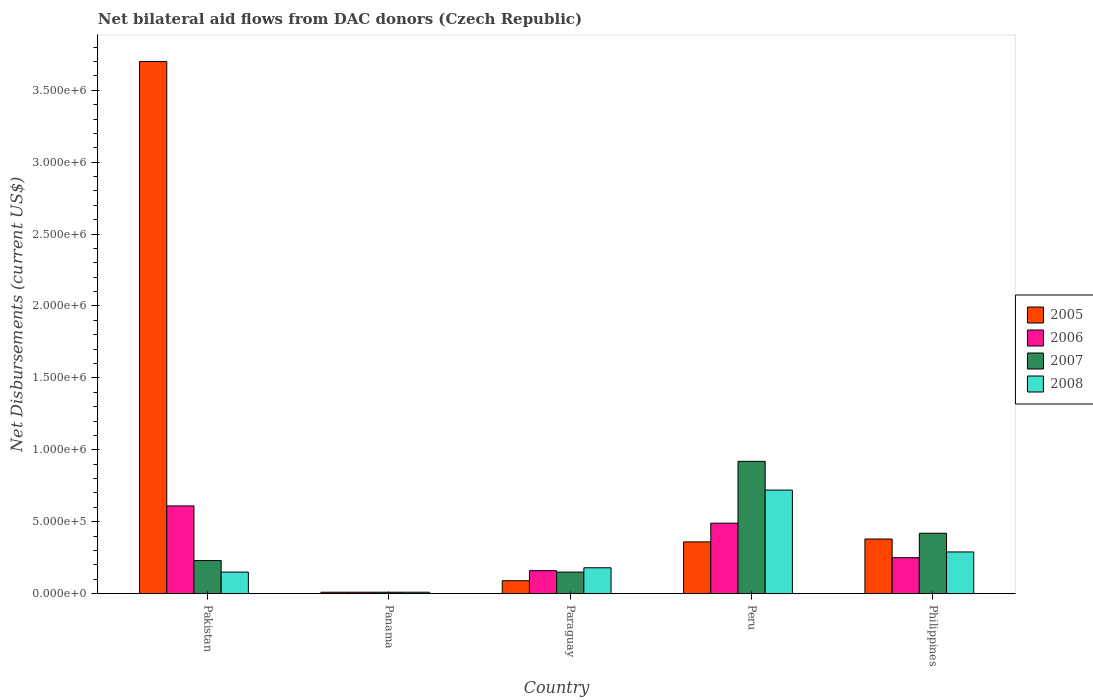How many bars are there on the 2nd tick from the right?
Your answer should be compact. 4. Across all countries, what is the maximum net bilateral aid flows in 2005?
Offer a terse response. 3.70e+06. In which country was the net bilateral aid flows in 2006 maximum?
Keep it short and to the point. Pakistan. In which country was the net bilateral aid flows in 2007 minimum?
Offer a terse response. Panama. What is the total net bilateral aid flows in 2005 in the graph?
Give a very brief answer. 4.54e+06. What is the difference between the net bilateral aid flows in 2005 in Pakistan and that in Peru?
Your response must be concise. 3.34e+06. What is the difference between the net bilateral aid flows in 2007 in Paraguay and the net bilateral aid flows in 2006 in Pakistan?
Give a very brief answer. -4.60e+05. What is the average net bilateral aid flows in 2006 per country?
Make the answer very short. 3.04e+05. What is the difference between the net bilateral aid flows of/in 2005 and net bilateral aid flows of/in 2007 in Pakistan?
Offer a very short reply. 3.47e+06. In how many countries, is the net bilateral aid flows in 2007 greater than 1800000 US$?
Your answer should be compact. 0. What is the difference between the highest and the second highest net bilateral aid flows in 2005?
Offer a terse response. 3.34e+06. What is the difference between the highest and the lowest net bilateral aid flows in 2005?
Keep it short and to the point. 3.69e+06. In how many countries, is the net bilateral aid flows in 2006 greater than the average net bilateral aid flows in 2006 taken over all countries?
Your answer should be compact. 2. Is the sum of the net bilateral aid flows in 2007 in Pakistan and Peru greater than the maximum net bilateral aid flows in 2006 across all countries?
Give a very brief answer. Yes. Is it the case that in every country, the sum of the net bilateral aid flows in 2006 and net bilateral aid flows in 2005 is greater than the sum of net bilateral aid flows in 2007 and net bilateral aid flows in 2008?
Ensure brevity in your answer.  No. What does the 3rd bar from the left in Philippines represents?
Give a very brief answer. 2007. Are all the bars in the graph horizontal?
Provide a succinct answer. No. Are the values on the major ticks of Y-axis written in scientific E-notation?
Your response must be concise. Yes. Does the graph contain any zero values?
Give a very brief answer. No. Does the graph contain grids?
Offer a terse response. No. What is the title of the graph?
Offer a very short reply. Net bilateral aid flows from DAC donors (Czech Republic). Does "1984" appear as one of the legend labels in the graph?
Give a very brief answer. No. What is the label or title of the Y-axis?
Offer a very short reply. Net Disbursements (current US$). What is the Net Disbursements (current US$) in 2005 in Pakistan?
Give a very brief answer. 3.70e+06. What is the Net Disbursements (current US$) in 2008 in Pakistan?
Your response must be concise. 1.50e+05. What is the Net Disbursements (current US$) in 2005 in Panama?
Offer a terse response. 10000. What is the Net Disbursements (current US$) of 2005 in Paraguay?
Keep it short and to the point. 9.00e+04. What is the Net Disbursements (current US$) of 2007 in Paraguay?
Provide a short and direct response. 1.50e+05. What is the Net Disbursements (current US$) of 2005 in Peru?
Provide a succinct answer. 3.60e+05. What is the Net Disbursements (current US$) in 2006 in Peru?
Provide a succinct answer. 4.90e+05. What is the Net Disbursements (current US$) of 2007 in Peru?
Provide a succinct answer. 9.20e+05. What is the Net Disbursements (current US$) of 2008 in Peru?
Make the answer very short. 7.20e+05. What is the Net Disbursements (current US$) of 2006 in Philippines?
Your answer should be very brief. 2.50e+05. What is the Net Disbursements (current US$) in 2007 in Philippines?
Your answer should be very brief. 4.20e+05. Across all countries, what is the maximum Net Disbursements (current US$) in 2005?
Offer a very short reply. 3.70e+06. Across all countries, what is the maximum Net Disbursements (current US$) of 2007?
Provide a succinct answer. 9.20e+05. Across all countries, what is the maximum Net Disbursements (current US$) of 2008?
Offer a terse response. 7.20e+05. Across all countries, what is the minimum Net Disbursements (current US$) in 2007?
Your answer should be compact. 10000. What is the total Net Disbursements (current US$) in 2005 in the graph?
Your answer should be very brief. 4.54e+06. What is the total Net Disbursements (current US$) in 2006 in the graph?
Your answer should be compact. 1.52e+06. What is the total Net Disbursements (current US$) of 2007 in the graph?
Offer a terse response. 1.73e+06. What is the total Net Disbursements (current US$) in 2008 in the graph?
Offer a terse response. 1.35e+06. What is the difference between the Net Disbursements (current US$) of 2005 in Pakistan and that in Panama?
Keep it short and to the point. 3.69e+06. What is the difference between the Net Disbursements (current US$) of 2006 in Pakistan and that in Panama?
Your answer should be very brief. 6.00e+05. What is the difference between the Net Disbursements (current US$) in 2005 in Pakistan and that in Paraguay?
Make the answer very short. 3.61e+06. What is the difference between the Net Disbursements (current US$) of 2006 in Pakistan and that in Paraguay?
Your answer should be compact. 4.50e+05. What is the difference between the Net Disbursements (current US$) of 2007 in Pakistan and that in Paraguay?
Provide a short and direct response. 8.00e+04. What is the difference between the Net Disbursements (current US$) in 2005 in Pakistan and that in Peru?
Your answer should be very brief. 3.34e+06. What is the difference between the Net Disbursements (current US$) in 2007 in Pakistan and that in Peru?
Ensure brevity in your answer.  -6.90e+05. What is the difference between the Net Disbursements (current US$) of 2008 in Pakistan and that in Peru?
Offer a very short reply. -5.70e+05. What is the difference between the Net Disbursements (current US$) in 2005 in Pakistan and that in Philippines?
Your answer should be compact. 3.32e+06. What is the difference between the Net Disbursements (current US$) in 2006 in Pakistan and that in Philippines?
Offer a very short reply. 3.60e+05. What is the difference between the Net Disbursements (current US$) of 2007 in Pakistan and that in Philippines?
Give a very brief answer. -1.90e+05. What is the difference between the Net Disbursements (current US$) in 2005 in Panama and that in Paraguay?
Offer a terse response. -8.00e+04. What is the difference between the Net Disbursements (current US$) in 2006 in Panama and that in Paraguay?
Offer a very short reply. -1.50e+05. What is the difference between the Net Disbursements (current US$) in 2005 in Panama and that in Peru?
Provide a succinct answer. -3.50e+05. What is the difference between the Net Disbursements (current US$) of 2006 in Panama and that in Peru?
Your response must be concise. -4.80e+05. What is the difference between the Net Disbursements (current US$) in 2007 in Panama and that in Peru?
Offer a terse response. -9.10e+05. What is the difference between the Net Disbursements (current US$) of 2008 in Panama and that in Peru?
Your response must be concise. -7.10e+05. What is the difference between the Net Disbursements (current US$) of 2005 in Panama and that in Philippines?
Provide a succinct answer. -3.70e+05. What is the difference between the Net Disbursements (current US$) of 2006 in Panama and that in Philippines?
Provide a succinct answer. -2.40e+05. What is the difference between the Net Disbursements (current US$) in 2007 in Panama and that in Philippines?
Your response must be concise. -4.10e+05. What is the difference between the Net Disbursements (current US$) of 2008 in Panama and that in Philippines?
Offer a very short reply. -2.80e+05. What is the difference between the Net Disbursements (current US$) in 2006 in Paraguay and that in Peru?
Make the answer very short. -3.30e+05. What is the difference between the Net Disbursements (current US$) of 2007 in Paraguay and that in Peru?
Give a very brief answer. -7.70e+05. What is the difference between the Net Disbursements (current US$) in 2008 in Paraguay and that in Peru?
Your response must be concise. -5.40e+05. What is the difference between the Net Disbursements (current US$) of 2005 in Paraguay and that in Philippines?
Provide a short and direct response. -2.90e+05. What is the difference between the Net Disbursements (current US$) in 2008 in Paraguay and that in Philippines?
Offer a terse response. -1.10e+05. What is the difference between the Net Disbursements (current US$) in 2005 in Peru and that in Philippines?
Make the answer very short. -2.00e+04. What is the difference between the Net Disbursements (current US$) of 2005 in Pakistan and the Net Disbursements (current US$) of 2006 in Panama?
Offer a very short reply. 3.69e+06. What is the difference between the Net Disbursements (current US$) of 2005 in Pakistan and the Net Disbursements (current US$) of 2007 in Panama?
Ensure brevity in your answer.  3.69e+06. What is the difference between the Net Disbursements (current US$) in 2005 in Pakistan and the Net Disbursements (current US$) in 2008 in Panama?
Provide a short and direct response. 3.69e+06. What is the difference between the Net Disbursements (current US$) of 2006 in Pakistan and the Net Disbursements (current US$) of 2007 in Panama?
Make the answer very short. 6.00e+05. What is the difference between the Net Disbursements (current US$) of 2007 in Pakistan and the Net Disbursements (current US$) of 2008 in Panama?
Your answer should be very brief. 2.20e+05. What is the difference between the Net Disbursements (current US$) of 2005 in Pakistan and the Net Disbursements (current US$) of 2006 in Paraguay?
Provide a short and direct response. 3.54e+06. What is the difference between the Net Disbursements (current US$) of 2005 in Pakistan and the Net Disbursements (current US$) of 2007 in Paraguay?
Offer a terse response. 3.55e+06. What is the difference between the Net Disbursements (current US$) in 2005 in Pakistan and the Net Disbursements (current US$) in 2008 in Paraguay?
Provide a succinct answer. 3.52e+06. What is the difference between the Net Disbursements (current US$) of 2006 in Pakistan and the Net Disbursements (current US$) of 2007 in Paraguay?
Offer a very short reply. 4.60e+05. What is the difference between the Net Disbursements (current US$) in 2006 in Pakistan and the Net Disbursements (current US$) in 2008 in Paraguay?
Ensure brevity in your answer.  4.30e+05. What is the difference between the Net Disbursements (current US$) in 2007 in Pakistan and the Net Disbursements (current US$) in 2008 in Paraguay?
Keep it short and to the point. 5.00e+04. What is the difference between the Net Disbursements (current US$) in 2005 in Pakistan and the Net Disbursements (current US$) in 2006 in Peru?
Provide a short and direct response. 3.21e+06. What is the difference between the Net Disbursements (current US$) in 2005 in Pakistan and the Net Disbursements (current US$) in 2007 in Peru?
Your response must be concise. 2.78e+06. What is the difference between the Net Disbursements (current US$) of 2005 in Pakistan and the Net Disbursements (current US$) of 2008 in Peru?
Your answer should be very brief. 2.98e+06. What is the difference between the Net Disbursements (current US$) of 2006 in Pakistan and the Net Disbursements (current US$) of 2007 in Peru?
Ensure brevity in your answer.  -3.10e+05. What is the difference between the Net Disbursements (current US$) of 2007 in Pakistan and the Net Disbursements (current US$) of 2008 in Peru?
Your response must be concise. -4.90e+05. What is the difference between the Net Disbursements (current US$) of 2005 in Pakistan and the Net Disbursements (current US$) of 2006 in Philippines?
Make the answer very short. 3.45e+06. What is the difference between the Net Disbursements (current US$) of 2005 in Pakistan and the Net Disbursements (current US$) of 2007 in Philippines?
Provide a succinct answer. 3.28e+06. What is the difference between the Net Disbursements (current US$) of 2005 in Pakistan and the Net Disbursements (current US$) of 2008 in Philippines?
Offer a terse response. 3.41e+06. What is the difference between the Net Disbursements (current US$) in 2006 in Pakistan and the Net Disbursements (current US$) in 2007 in Philippines?
Provide a short and direct response. 1.90e+05. What is the difference between the Net Disbursements (current US$) in 2006 in Pakistan and the Net Disbursements (current US$) in 2008 in Philippines?
Keep it short and to the point. 3.20e+05. What is the difference between the Net Disbursements (current US$) in 2007 in Pakistan and the Net Disbursements (current US$) in 2008 in Philippines?
Offer a very short reply. -6.00e+04. What is the difference between the Net Disbursements (current US$) of 2005 in Panama and the Net Disbursements (current US$) of 2006 in Peru?
Ensure brevity in your answer.  -4.80e+05. What is the difference between the Net Disbursements (current US$) of 2005 in Panama and the Net Disbursements (current US$) of 2007 in Peru?
Give a very brief answer. -9.10e+05. What is the difference between the Net Disbursements (current US$) in 2005 in Panama and the Net Disbursements (current US$) in 2008 in Peru?
Provide a short and direct response. -7.10e+05. What is the difference between the Net Disbursements (current US$) of 2006 in Panama and the Net Disbursements (current US$) of 2007 in Peru?
Your answer should be compact. -9.10e+05. What is the difference between the Net Disbursements (current US$) of 2006 in Panama and the Net Disbursements (current US$) of 2008 in Peru?
Your answer should be compact. -7.10e+05. What is the difference between the Net Disbursements (current US$) of 2007 in Panama and the Net Disbursements (current US$) of 2008 in Peru?
Offer a terse response. -7.10e+05. What is the difference between the Net Disbursements (current US$) of 2005 in Panama and the Net Disbursements (current US$) of 2007 in Philippines?
Ensure brevity in your answer.  -4.10e+05. What is the difference between the Net Disbursements (current US$) in 2005 in Panama and the Net Disbursements (current US$) in 2008 in Philippines?
Offer a very short reply. -2.80e+05. What is the difference between the Net Disbursements (current US$) of 2006 in Panama and the Net Disbursements (current US$) of 2007 in Philippines?
Keep it short and to the point. -4.10e+05. What is the difference between the Net Disbursements (current US$) in 2006 in Panama and the Net Disbursements (current US$) in 2008 in Philippines?
Provide a short and direct response. -2.80e+05. What is the difference between the Net Disbursements (current US$) in 2007 in Panama and the Net Disbursements (current US$) in 2008 in Philippines?
Give a very brief answer. -2.80e+05. What is the difference between the Net Disbursements (current US$) in 2005 in Paraguay and the Net Disbursements (current US$) in 2006 in Peru?
Your answer should be very brief. -4.00e+05. What is the difference between the Net Disbursements (current US$) in 2005 in Paraguay and the Net Disbursements (current US$) in 2007 in Peru?
Your response must be concise. -8.30e+05. What is the difference between the Net Disbursements (current US$) of 2005 in Paraguay and the Net Disbursements (current US$) of 2008 in Peru?
Your answer should be compact. -6.30e+05. What is the difference between the Net Disbursements (current US$) of 2006 in Paraguay and the Net Disbursements (current US$) of 2007 in Peru?
Give a very brief answer. -7.60e+05. What is the difference between the Net Disbursements (current US$) in 2006 in Paraguay and the Net Disbursements (current US$) in 2008 in Peru?
Keep it short and to the point. -5.60e+05. What is the difference between the Net Disbursements (current US$) of 2007 in Paraguay and the Net Disbursements (current US$) of 2008 in Peru?
Ensure brevity in your answer.  -5.70e+05. What is the difference between the Net Disbursements (current US$) in 2005 in Paraguay and the Net Disbursements (current US$) in 2006 in Philippines?
Your answer should be compact. -1.60e+05. What is the difference between the Net Disbursements (current US$) of 2005 in Paraguay and the Net Disbursements (current US$) of 2007 in Philippines?
Provide a succinct answer. -3.30e+05. What is the difference between the Net Disbursements (current US$) of 2007 in Paraguay and the Net Disbursements (current US$) of 2008 in Philippines?
Make the answer very short. -1.40e+05. What is the difference between the Net Disbursements (current US$) in 2005 in Peru and the Net Disbursements (current US$) in 2006 in Philippines?
Your answer should be very brief. 1.10e+05. What is the difference between the Net Disbursements (current US$) in 2005 in Peru and the Net Disbursements (current US$) in 2008 in Philippines?
Make the answer very short. 7.00e+04. What is the difference between the Net Disbursements (current US$) in 2006 in Peru and the Net Disbursements (current US$) in 2008 in Philippines?
Offer a very short reply. 2.00e+05. What is the difference between the Net Disbursements (current US$) of 2007 in Peru and the Net Disbursements (current US$) of 2008 in Philippines?
Your answer should be very brief. 6.30e+05. What is the average Net Disbursements (current US$) in 2005 per country?
Give a very brief answer. 9.08e+05. What is the average Net Disbursements (current US$) in 2006 per country?
Ensure brevity in your answer.  3.04e+05. What is the average Net Disbursements (current US$) of 2007 per country?
Your answer should be very brief. 3.46e+05. What is the average Net Disbursements (current US$) of 2008 per country?
Your response must be concise. 2.70e+05. What is the difference between the Net Disbursements (current US$) of 2005 and Net Disbursements (current US$) of 2006 in Pakistan?
Offer a very short reply. 3.09e+06. What is the difference between the Net Disbursements (current US$) of 2005 and Net Disbursements (current US$) of 2007 in Pakistan?
Provide a short and direct response. 3.47e+06. What is the difference between the Net Disbursements (current US$) in 2005 and Net Disbursements (current US$) in 2008 in Pakistan?
Provide a short and direct response. 3.55e+06. What is the difference between the Net Disbursements (current US$) of 2006 and Net Disbursements (current US$) of 2007 in Pakistan?
Your answer should be very brief. 3.80e+05. What is the difference between the Net Disbursements (current US$) in 2006 and Net Disbursements (current US$) in 2008 in Pakistan?
Your response must be concise. 4.60e+05. What is the difference between the Net Disbursements (current US$) of 2005 and Net Disbursements (current US$) of 2006 in Panama?
Your answer should be compact. 0. What is the difference between the Net Disbursements (current US$) of 2005 and Net Disbursements (current US$) of 2007 in Panama?
Make the answer very short. 0. What is the difference between the Net Disbursements (current US$) in 2006 and Net Disbursements (current US$) in 2007 in Panama?
Offer a very short reply. 0. What is the difference between the Net Disbursements (current US$) of 2006 and Net Disbursements (current US$) of 2008 in Panama?
Ensure brevity in your answer.  0. What is the difference between the Net Disbursements (current US$) of 2007 and Net Disbursements (current US$) of 2008 in Panama?
Ensure brevity in your answer.  0. What is the difference between the Net Disbursements (current US$) in 2005 and Net Disbursements (current US$) in 2006 in Paraguay?
Offer a terse response. -7.00e+04. What is the difference between the Net Disbursements (current US$) of 2005 and Net Disbursements (current US$) of 2007 in Paraguay?
Offer a very short reply. -6.00e+04. What is the difference between the Net Disbursements (current US$) in 2005 and Net Disbursements (current US$) in 2006 in Peru?
Offer a terse response. -1.30e+05. What is the difference between the Net Disbursements (current US$) in 2005 and Net Disbursements (current US$) in 2007 in Peru?
Offer a very short reply. -5.60e+05. What is the difference between the Net Disbursements (current US$) of 2005 and Net Disbursements (current US$) of 2008 in Peru?
Your response must be concise. -3.60e+05. What is the difference between the Net Disbursements (current US$) in 2006 and Net Disbursements (current US$) in 2007 in Peru?
Make the answer very short. -4.30e+05. What is the difference between the Net Disbursements (current US$) of 2005 and Net Disbursements (current US$) of 2006 in Philippines?
Your answer should be very brief. 1.30e+05. What is the difference between the Net Disbursements (current US$) in 2006 and Net Disbursements (current US$) in 2007 in Philippines?
Offer a very short reply. -1.70e+05. What is the ratio of the Net Disbursements (current US$) of 2005 in Pakistan to that in Panama?
Ensure brevity in your answer.  370. What is the ratio of the Net Disbursements (current US$) of 2006 in Pakistan to that in Panama?
Make the answer very short. 61. What is the ratio of the Net Disbursements (current US$) in 2008 in Pakistan to that in Panama?
Your response must be concise. 15. What is the ratio of the Net Disbursements (current US$) of 2005 in Pakistan to that in Paraguay?
Offer a terse response. 41.11. What is the ratio of the Net Disbursements (current US$) in 2006 in Pakistan to that in Paraguay?
Keep it short and to the point. 3.81. What is the ratio of the Net Disbursements (current US$) in 2007 in Pakistan to that in Paraguay?
Offer a terse response. 1.53. What is the ratio of the Net Disbursements (current US$) in 2005 in Pakistan to that in Peru?
Ensure brevity in your answer.  10.28. What is the ratio of the Net Disbursements (current US$) of 2006 in Pakistan to that in Peru?
Your answer should be very brief. 1.24. What is the ratio of the Net Disbursements (current US$) in 2007 in Pakistan to that in Peru?
Keep it short and to the point. 0.25. What is the ratio of the Net Disbursements (current US$) in 2008 in Pakistan to that in Peru?
Keep it short and to the point. 0.21. What is the ratio of the Net Disbursements (current US$) of 2005 in Pakistan to that in Philippines?
Give a very brief answer. 9.74. What is the ratio of the Net Disbursements (current US$) of 2006 in Pakistan to that in Philippines?
Make the answer very short. 2.44. What is the ratio of the Net Disbursements (current US$) in 2007 in Pakistan to that in Philippines?
Ensure brevity in your answer.  0.55. What is the ratio of the Net Disbursements (current US$) in 2008 in Pakistan to that in Philippines?
Make the answer very short. 0.52. What is the ratio of the Net Disbursements (current US$) in 2006 in Panama to that in Paraguay?
Keep it short and to the point. 0.06. What is the ratio of the Net Disbursements (current US$) of 2007 in Panama to that in Paraguay?
Provide a succinct answer. 0.07. What is the ratio of the Net Disbursements (current US$) in 2008 in Panama to that in Paraguay?
Provide a succinct answer. 0.06. What is the ratio of the Net Disbursements (current US$) of 2005 in Panama to that in Peru?
Ensure brevity in your answer.  0.03. What is the ratio of the Net Disbursements (current US$) in 2006 in Panama to that in Peru?
Give a very brief answer. 0.02. What is the ratio of the Net Disbursements (current US$) of 2007 in Panama to that in Peru?
Offer a terse response. 0.01. What is the ratio of the Net Disbursements (current US$) in 2008 in Panama to that in Peru?
Provide a short and direct response. 0.01. What is the ratio of the Net Disbursements (current US$) of 2005 in Panama to that in Philippines?
Make the answer very short. 0.03. What is the ratio of the Net Disbursements (current US$) of 2006 in Panama to that in Philippines?
Ensure brevity in your answer.  0.04. What is the ratio of the Net Disbursements (current US$) of 2007 in Panama to that in Philippines?
Your answer should be very brief. 0.02. What is the ratio of the Net Disbursements (current US$) of 2008 in Panama to that in Philippines?
Offer a very short reply. 0.03. What is the ratio of the Net Disbursements (current US$) in 2005 in Paraguay to that in Peru?
Offer a very short reply. 0.25. What is the ratio of the Net Disbursements (current US$) in 2006 in Paraguay to that in Peru?
Your answer should be compact. 0.33. What is the ratio of the Net Disbursements (current US$) in 2007 in Paraguay to that in Peru?
Ensure brevity in your answer.  0.16. What is the ratio of the Net Disbursements (current US$) of 2005 in Paraguay to that in Philippines?
Ensure brevity in your answer.  0.24. What is the ratio of the Net Disbursements (current US$) of 2006 in Paraguay to that in Philippines?
Give a very brief answer. 0.64. What is the ratio of the Net Disbursements (current US$) of 2007 in Paraguay to that in Philippines?
Give a very brief answer. 0.36. What is the ratio of the Net Disbursements (current US$) in 2008 in Paraguay to that in Philippines?
Give a very brief answer. 0.62. What is the ratio of the Net Disbursements (current US$) in 2005 in Peru to that in Philippines?
Offer a very short reply. 0.95. What is the ratio of the Net Disbursements (current US$) in 2006 in Peru to that in Philippines?
Make the answer very short. 1.96. What is the ratio of the Net Disbursements (current US$) in 2007 in Peru to that in Philippines?
Your response must be concise. 2.19. What is the ratio of the Net Disbursements (current US$) in 2008 in Peru to that in Philippines?
Keep it short and to the point. 2.48. What is the difference between the highest and the second highest Net Disbursements (current US$) in 2005?
Keep it short and to the point. 3.32e+06. What is the difference between the highest and the second highest Net Disbursements (current US$) in 2006?
Keep it short and to the point. 1.20e+05. What is the difference between the highest and the second highest Net Disbursements (current US$) of 2007?
Make the answer very short. 5.00e+05. What is the difference between the highest and the second highest Net Disbursements (current US$) of 2008?
Provide a succinct answer. 4.30e+05. What is the difference between the highest and the lowest Net Disbursements (current US$) of 2005?
Your answer should be very brief. 3.69e+06. What is the difference between the highest and the lowest Net Disbursements (current US$) of 2006?
Give a very brief answer. 6.00e+05. What is the difference between the highest and the lowest Net Disbursements (current US$) of 2007?
Your answer should be very brief. 9.10e+05. What is the difference between the highest and the lowest Net Disbursements (current US$) in 2008?
Provide a succinct answer. 7.10e+05. 